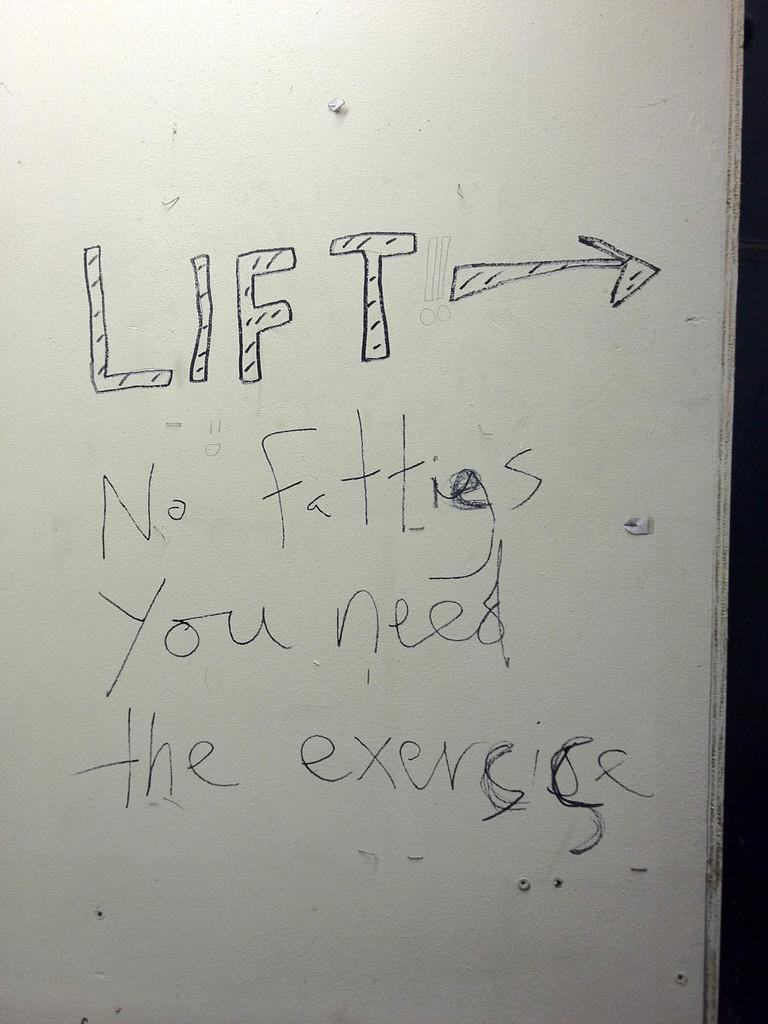<image>
Present a compact description of the photo's key features. Someone has written LIFT on a white wall, and a note about people needing the exercise. 